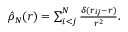Convert formula to latex. <formula><loc_0><loc_0><loc_500><loc_500>\begin{array} { r } { \hat { \rho } _ { N } ( r ) = \sum _ { i < j } ^ { N } \frac { \delta ( r _ { i j } - r ) } { r ^ { 2 } } . } \end{array}</formula> 